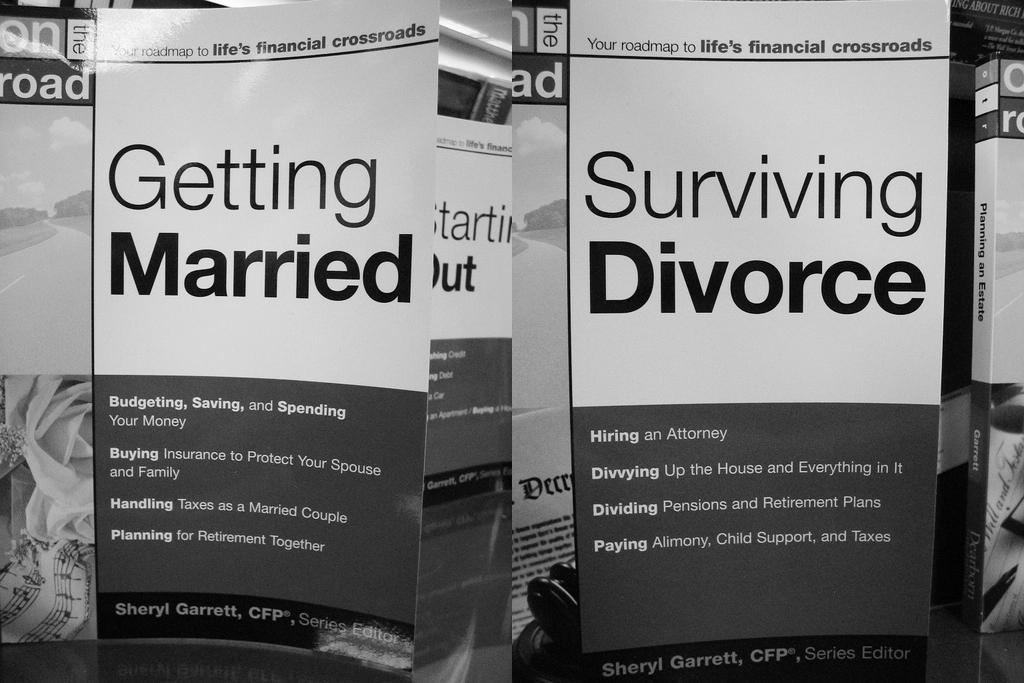<image>
Give a short and clear explanation of the subsequent image. Books about getting married and surviving divorce are next to each other. 